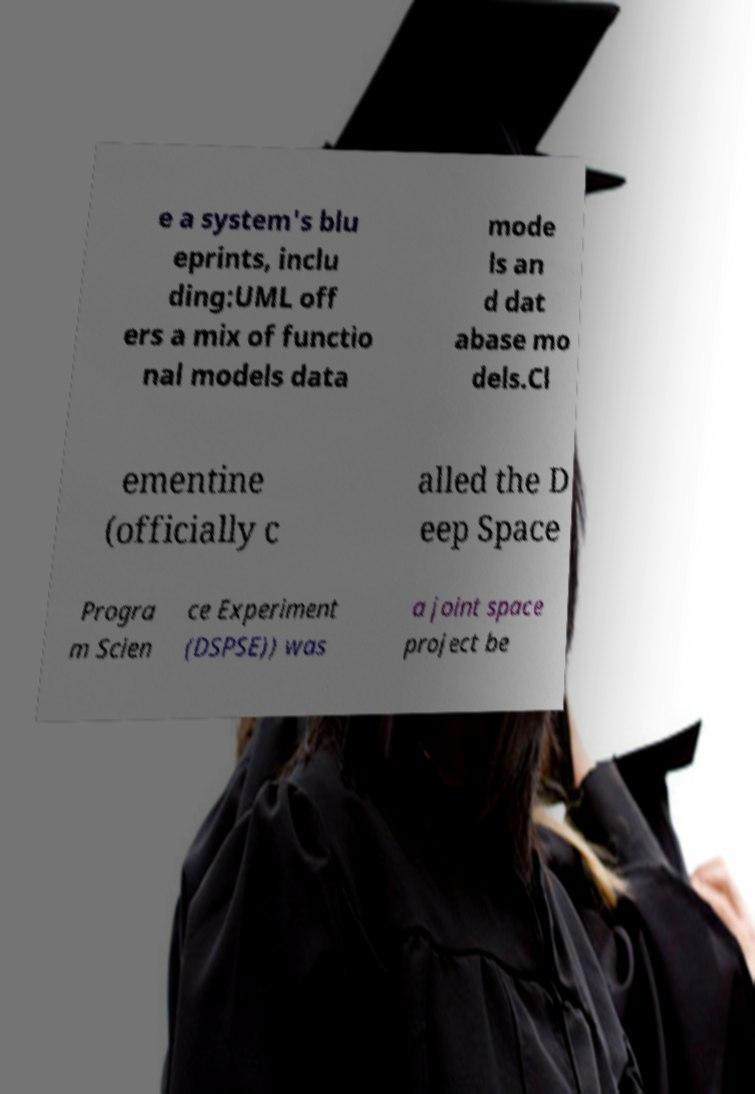Can you read and provide the text displayed in the image?This photo seems to have some interesting text. Can you extract and type it out for me? e a system's blu eprints, inclu ding:UML off ers a mix of functio nal models data mode ls an d dat abase mo dels.Cl ementine (officially c alled the D eep Space Progra m Scien ce Experiment (DSPSE)) was a joint space project be 